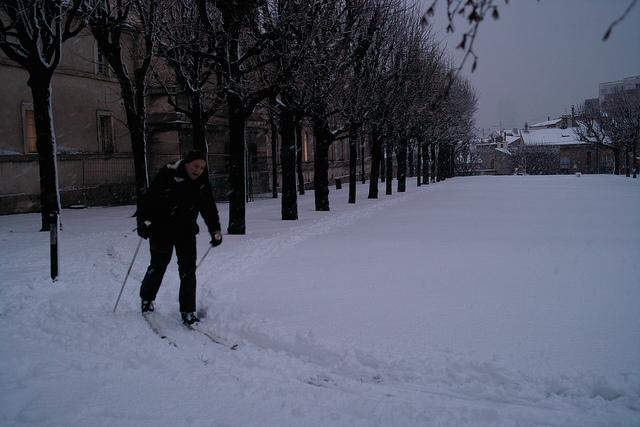How many dogs are there?
Give a very brief answer. 0. How many buses can be seen in this photo?
Give a very brief answer. 0. 